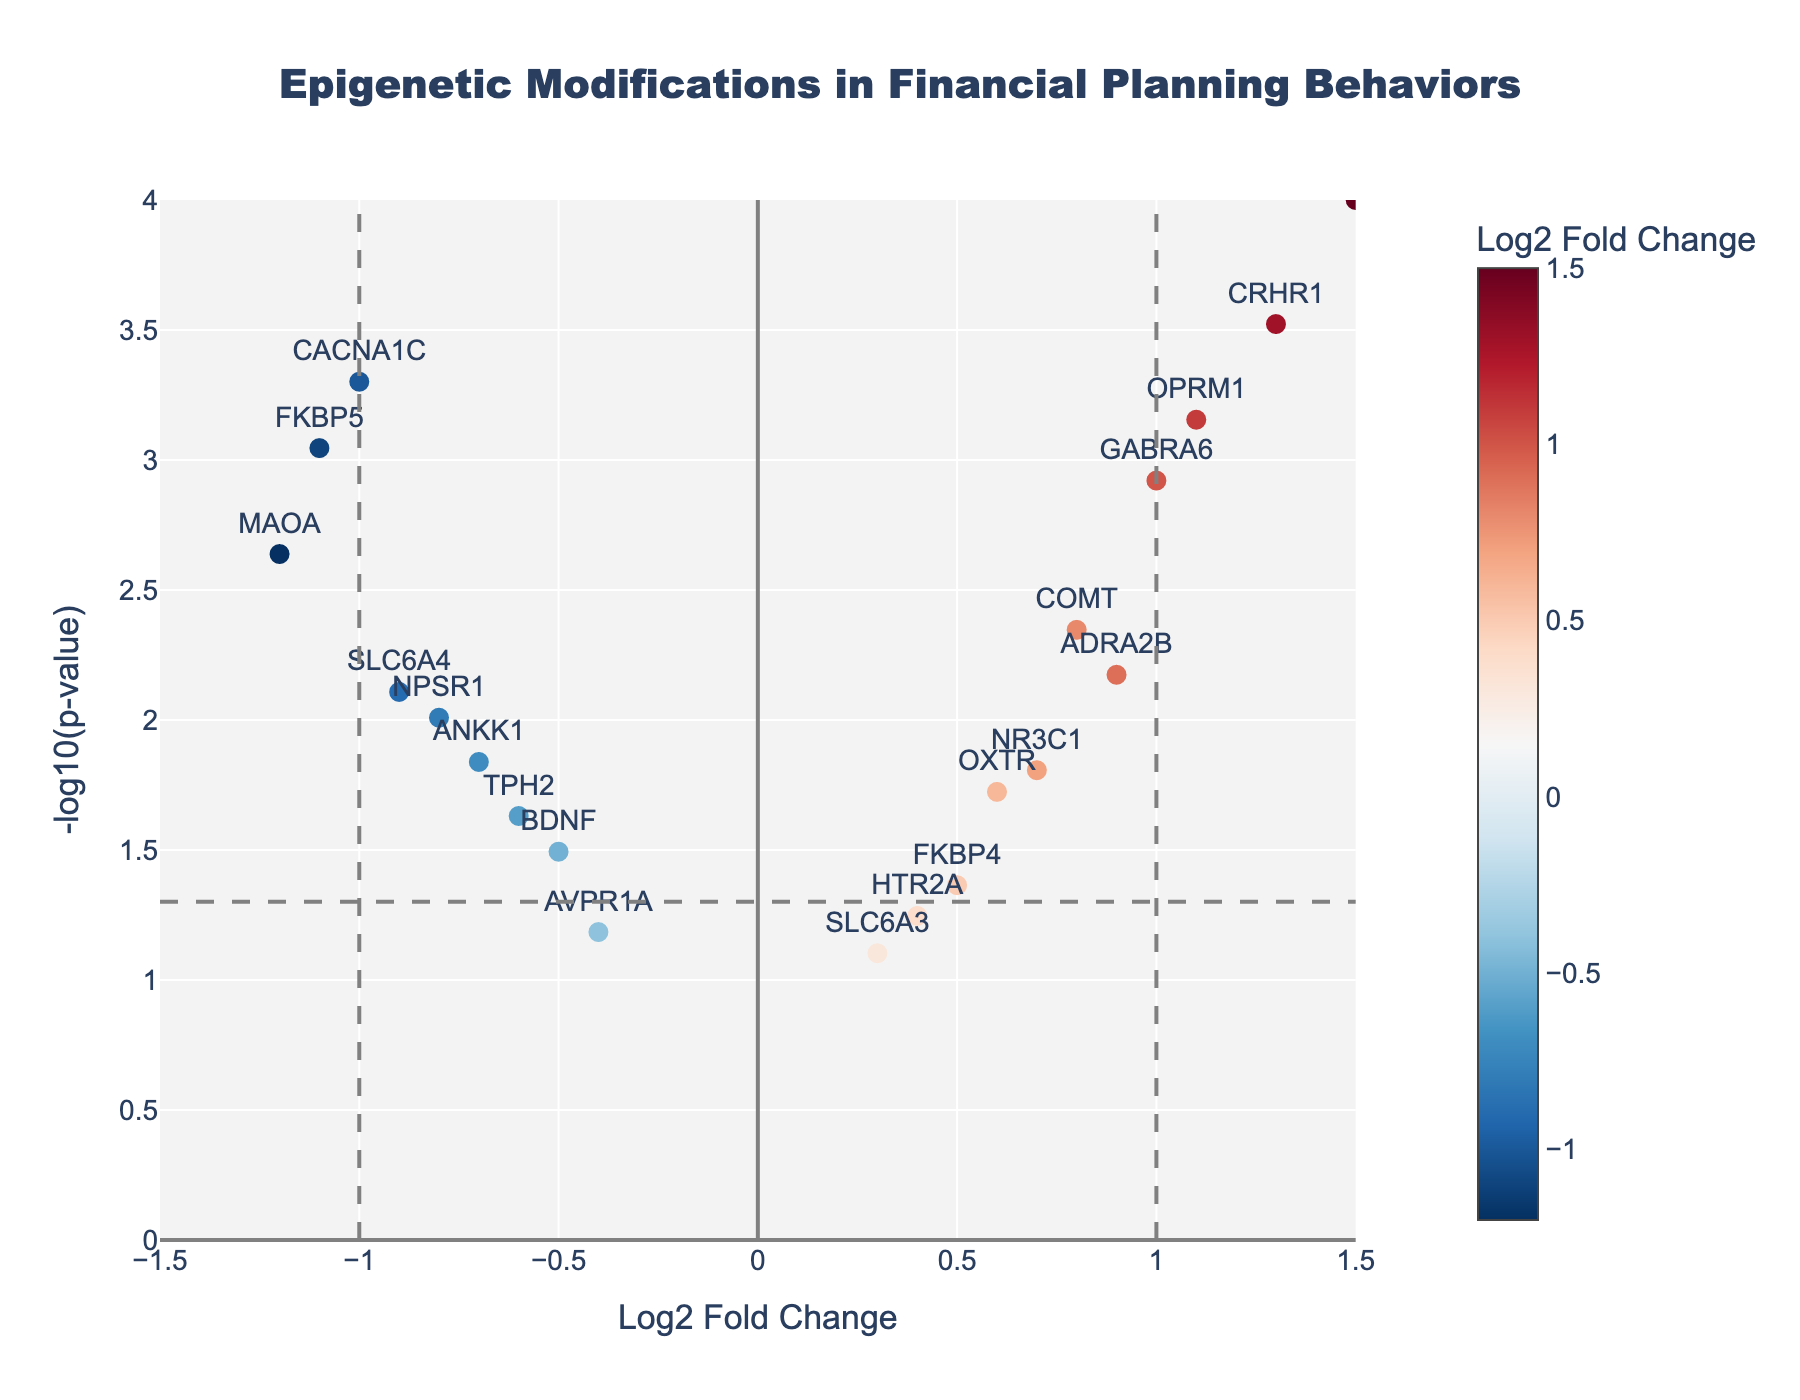How many genes have a log2 fold change greater than 1? By examining the plot, we look for data points right of the vertical line x=1. These genes are DRD4, CRHR1, GABRA6, OPRM1. Therefore, there are 4 genes with a log2 fold change greater than 1.
Answer: 4 What is the gene with the smallest p-value? By identifying the gene that has the highest value on the y-axis (-log10(p-value)), we see that DRD4 has the highest point, indicating the smallest p-value.
Answer: DRD4 Which gene has the highest negative log2 fold change? We focus on the left side of the plot (negative log2 fold change). The lowest point on the x-axis is for MAOA with a value of -1.2.
Answer: MAOA How many genes are significantly differentially expressed at p-value < 0.05? We look for data points above the horizontal line y = -log10(0.05). These genes are MAOA, COMT, DRD4, SLC6A4, FKBP5, NR3C1, CRHR1, GABRA6, ADRA2B, TPH2, ANKK1, OPRM1, CACNA1C, and NPSR1, totaling 14 genes.
Answer: 14 Which genes have both a log2 fold change greater than 0 and a p-value less than 0.01? We look for points to the right of the y-axis and above y = -log10(0.01). These genes are DRD4, CRHR1, GABRA6, ADRA2B, and OPRM1.
Answer: DRD4, CRHR1, GABRA6, ADRA2B, OPRM1 What is the log2 fold change and p-value of FKBP5? By looking at the specific data point for FKBP5, we find that its position is at -1.1 on the x-axis and 0.0009 on the y-axis.
Answer: -1.1, 0.0009 Which gene has the lowest significant log2 fold change? From the data points above the horizontal significance line (y = -log10(0.05)), the gene with the smallest log2 fold change is MAOA at -1.2.
Answer: MAOA What does the vertical line at x=-1 indicate? It's a threshold used to differentiate between significant negative log2 fold changes. Genes to the left of this line are considered significantly downregulated.
Answer: Threshold for significant downregulation Which gene has a log2 fold change closest to zero and is significant? We look for the point closest to the y-axis (log2 fold change close to 0) and above the horizontal line (significance threshold). The closest data point is HTR2A with a log2 fold change of 0.4.
Answer: HTR2A How many genes are downregulated with a significant p-value? We look for data points left of the y-axis and above the horizontal significance line. The genes are MAOA, SLC6A4, FKBP5, CACNA1C, ANKK1, and NPSR1, totaling 6.
Answer: 6 